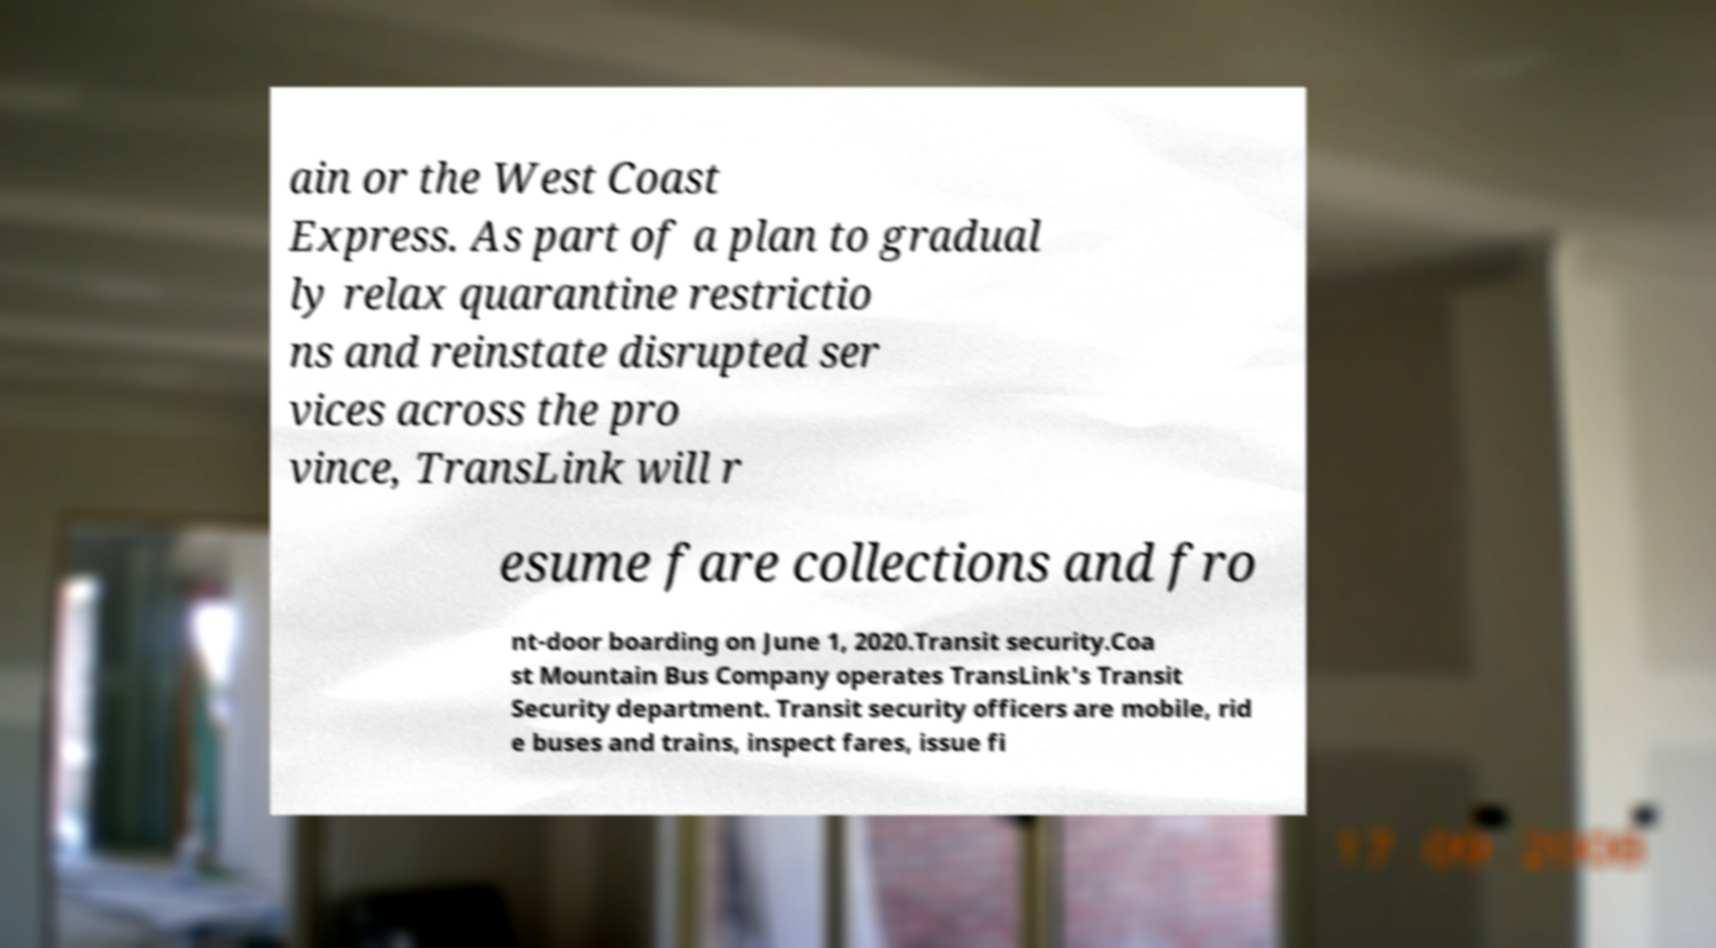Can you read and provide the text displayed in the image?This photo seems to have some interesting text. Can you extract and type it out for me? ain or the West Coast Express. As part of a plan to gradual ly relax quarantine restrictio ns and reinstate disrupted ser vices across the pro vince, TransLink will r esume fare collections and fro nt-door boarding on June 1, 2020.Transit security.Coa st Mountain Bus Company operates TransLink's Transit Security department. Transit security officers are mobile, rid e buses and trains, inspect fares, issue fi 